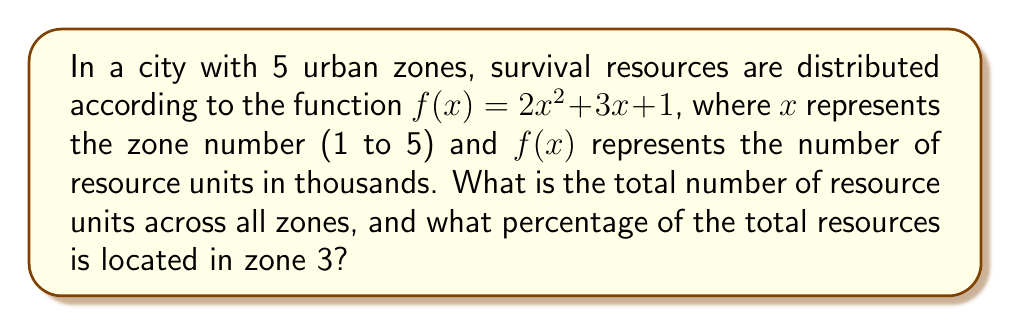Show me your answer to this math problem. 1) First, let's calculate the resources in each zone:

   Zone 1: $f(1) = 2(1)^2 + 3(1) + 1 = 2 + 3 + 1 = 6$ thousand units
   Zone 2: $f(2) = 2(2)^2 + 3(2) + 1 = 8 + 6 + 1 = 15$ thousand units
   Zone 3: $f(3) = 2(3)^2 + 3(3) + 1 = 18 + 9 + 1 = 28$ thousand units
   Zone 4: $f(4) = 2(4)^2 + 3(4) + 1 = 32 + 12 + 1 = 45$ thousand units
   Zone 5: $f(5) = 2(5)^2 + 3(5) + 1 = 50 + 15 + 1 = 66$ thousand units

2) Total resources:
   $6 + 15 + 28 + 45 + 66 = 160$ thousand units

3) Resources in Zone 3:
   28 thousand units

4) Percentage of resources in Zone 3:
   $\frac{28}{160} \times 100\% = 17.5\%$

Therefore, the total number of resource units across all zones is 160,000, and 17.5% of the total resources are located in zone 3.
Answer: 160,000 units; 17.5% 